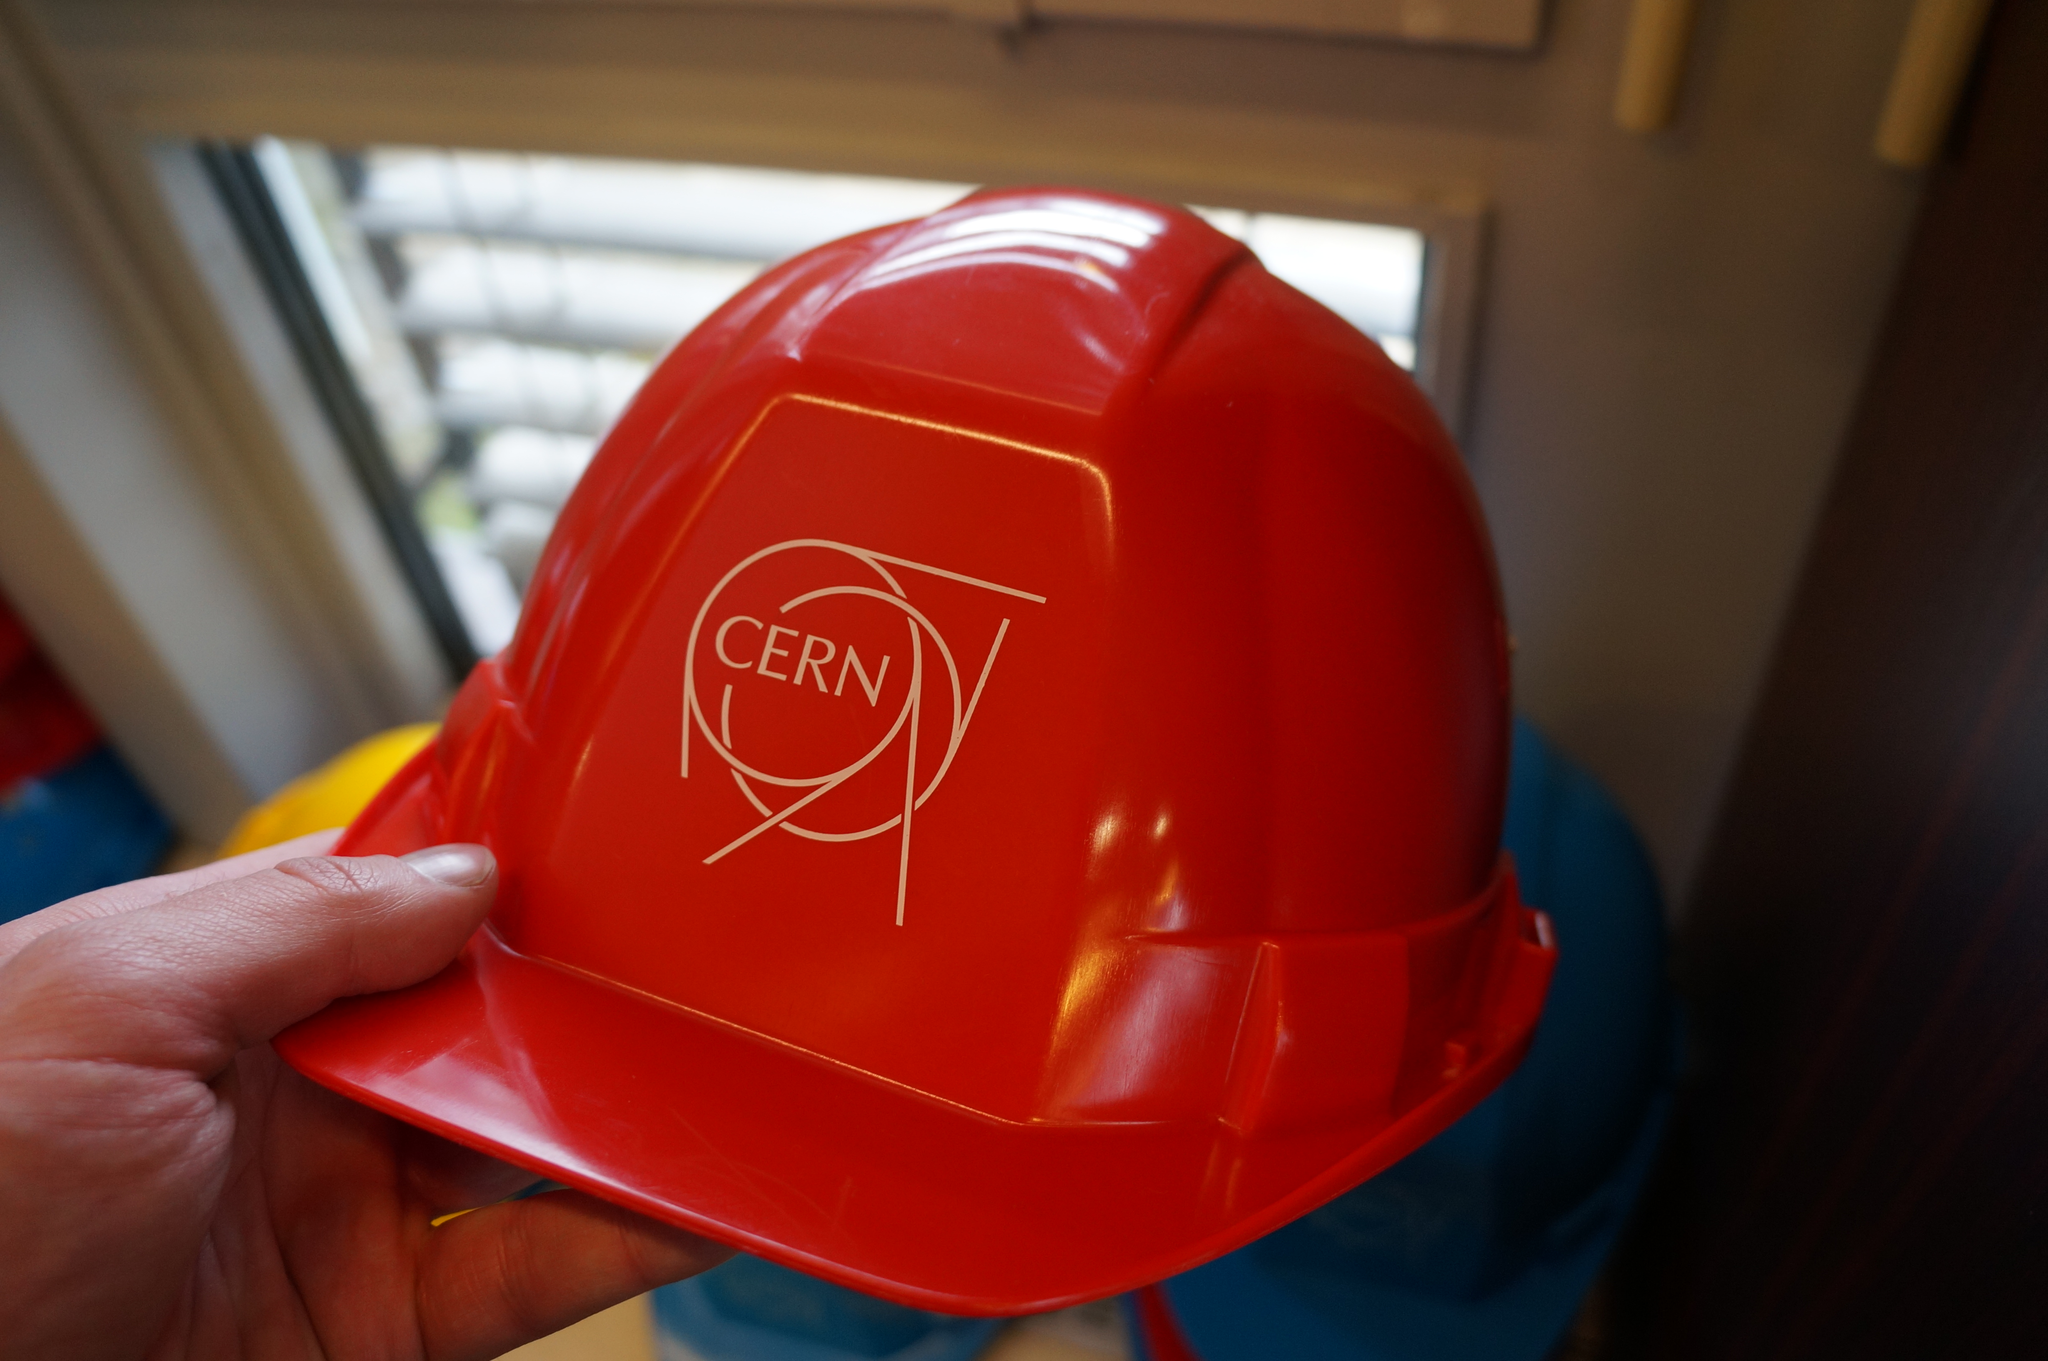How would you summarize this image in a sentence or two? In this image there is a person holding a red color hat, and there is blur background. 